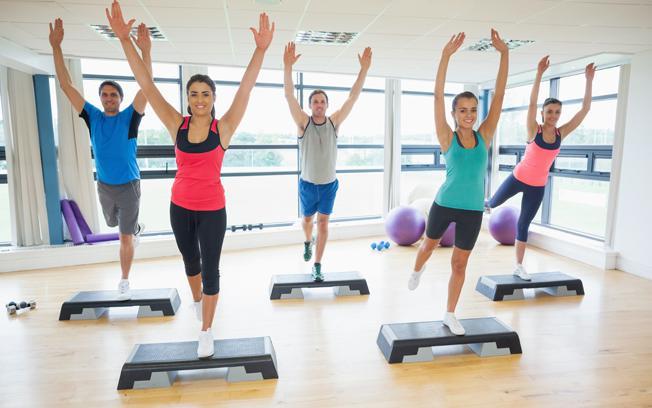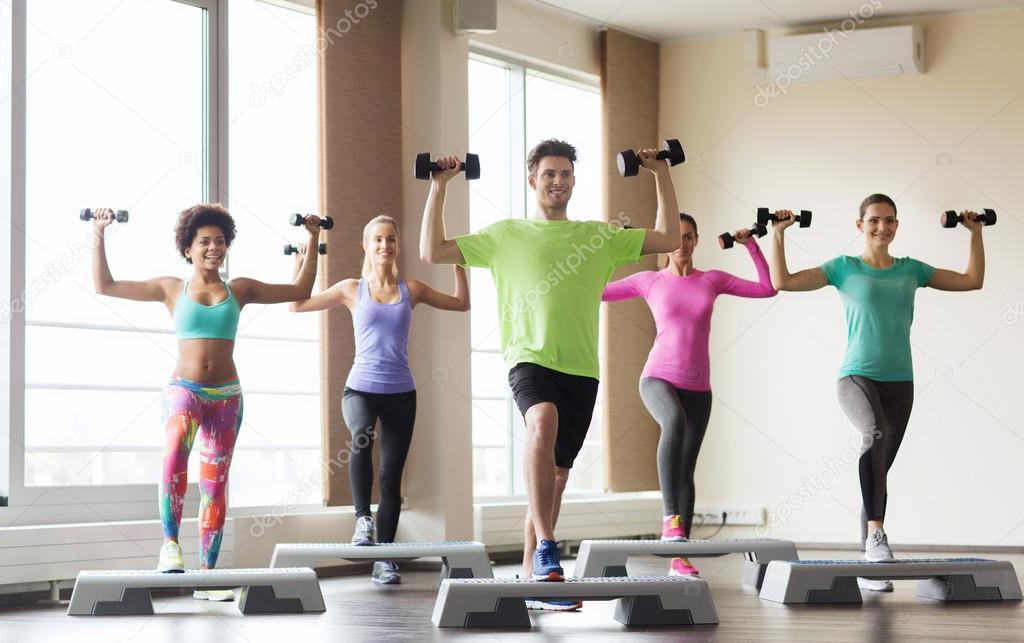The first image is the image on the left, the second image is the image on the right. Considering the images on both sides, is "In at least one image there are three people lifting weights." valid? Answer yes or no. No. The first image is the image on the left, the second image is the image on the right. Assess this claim about the two images: "One image shows a man holding something weighted in each hand, standing in front of at least four women doing the same workout.". Correct or not? Answer yes or no. Yes. 